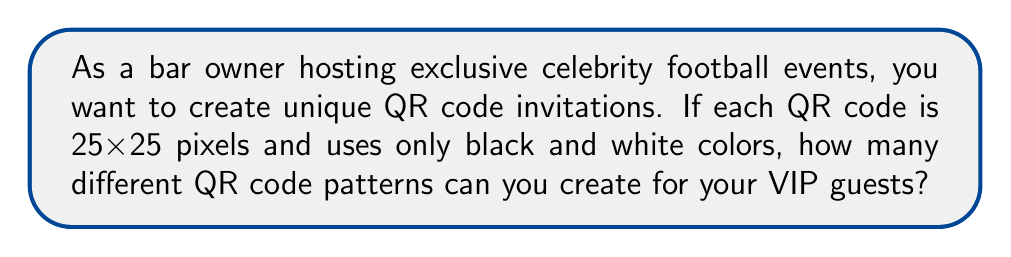Solve this math problem. Let's approach this step-by-step:

1) First, we need to understand what determines the number of unique QR codes:
   - The size of the QR code (25x25 pixels)
   - The number of possible colors for each pixel (2: black and white)

2) In a 25x25 QR code, there are $25 \times 25 = 625$ total pixels.

3) For each pixel, we have 2 choices (black or white).

4) To calculate the total number of possible combinations, we use the multiplication principle:
   - For each of the 625 pixels, we have 2 choices
   - This can be represented as $2^{625}$

5) To calculate this:
   $$2^{625} = 2^{600} \times 2^{25}$$
   
   $$2^{600} \approx 3.94 \times 10^{180}$$
   $$2^{25} = 33,554,432$$

   $$2^{625} \approx (3.94 \times 10^{180}) \times (3.36 \times 10^7) \approx 1.32 \times 10^{188}$$

6) This number is astronomically large, far exceeding the number of VIP guests you'd ever need to invite.
Answer: $\approx 1.32 \times 10^{188}$ unique QR code patterns 